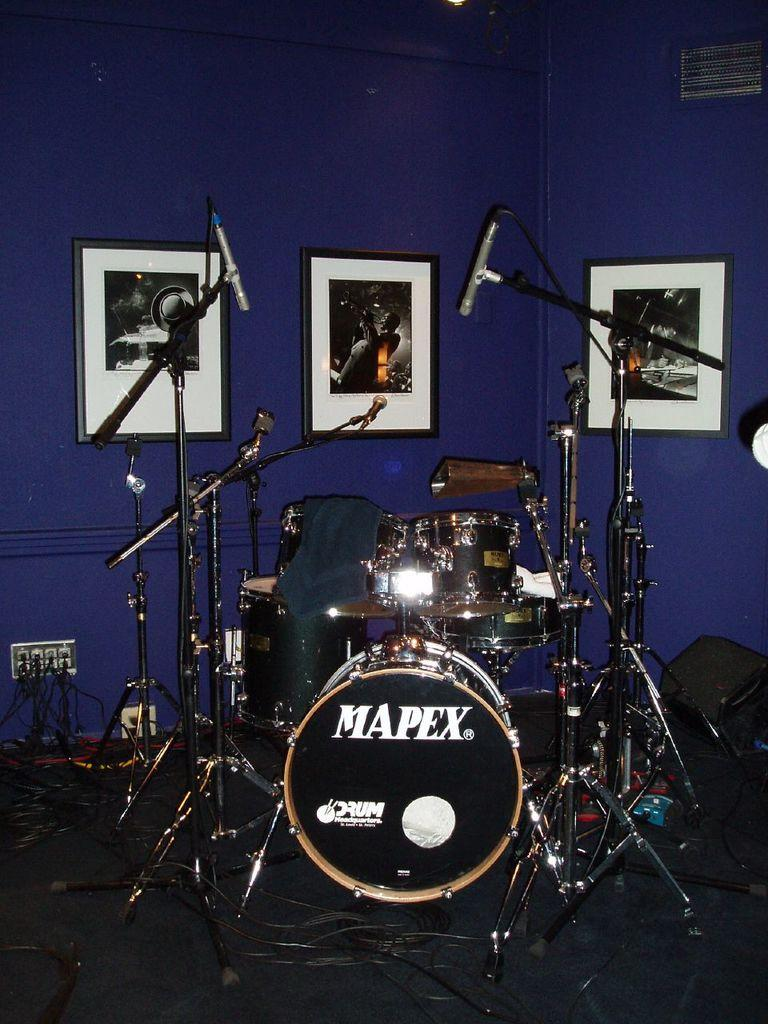What can be seen in the image related to music performance? There is a band setup in the image. What equipment is used by the band members for vocal performance? Microphones are present in the image. What can be seen on the wall in the background? There are three frames on the wall in the background. What color is the wall in the image? The wall is blue. What surface is visible beneath the band setup? There is a floor visible in the image. What type of advertisement can be seen on the floor in the image? There is no advertisement present on the floor in the image. What kind of rifle is visible in the hands of the band members? There are no rifles present in the image; the band members are using microphones for their performance. 